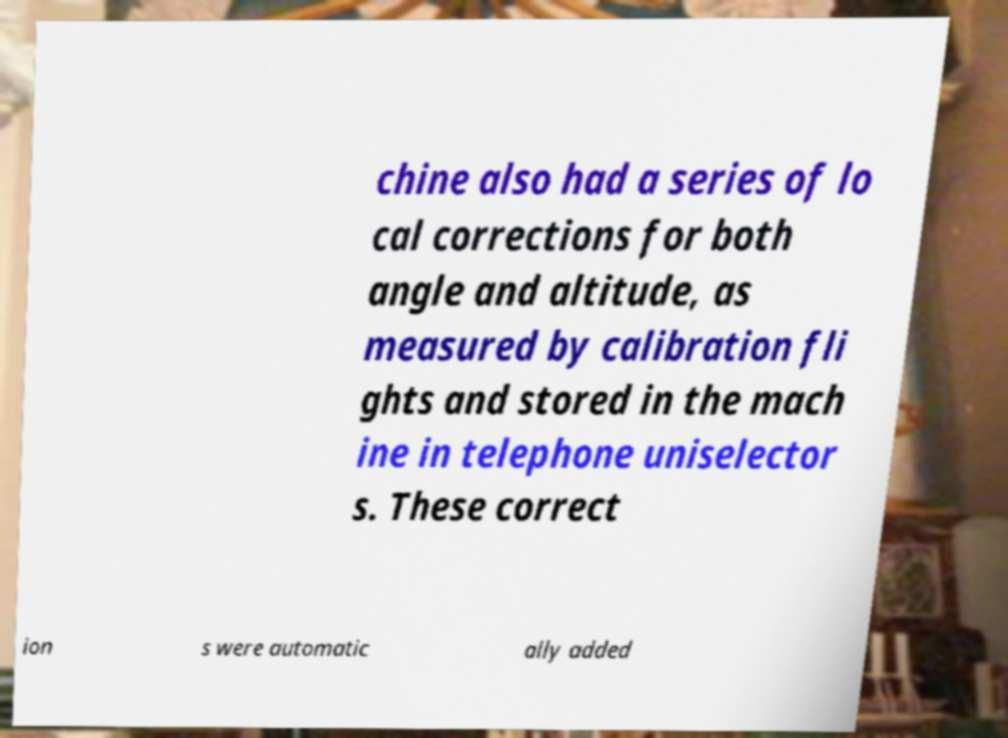I need the written content from this picture converted into text. Can you do that? chine also had a series of lo cal corrections for both angle and altitude, as measured by calibration fli ghts and stored in the mach ine in telephone uniselector s. These correct ion s were automatic ally added 